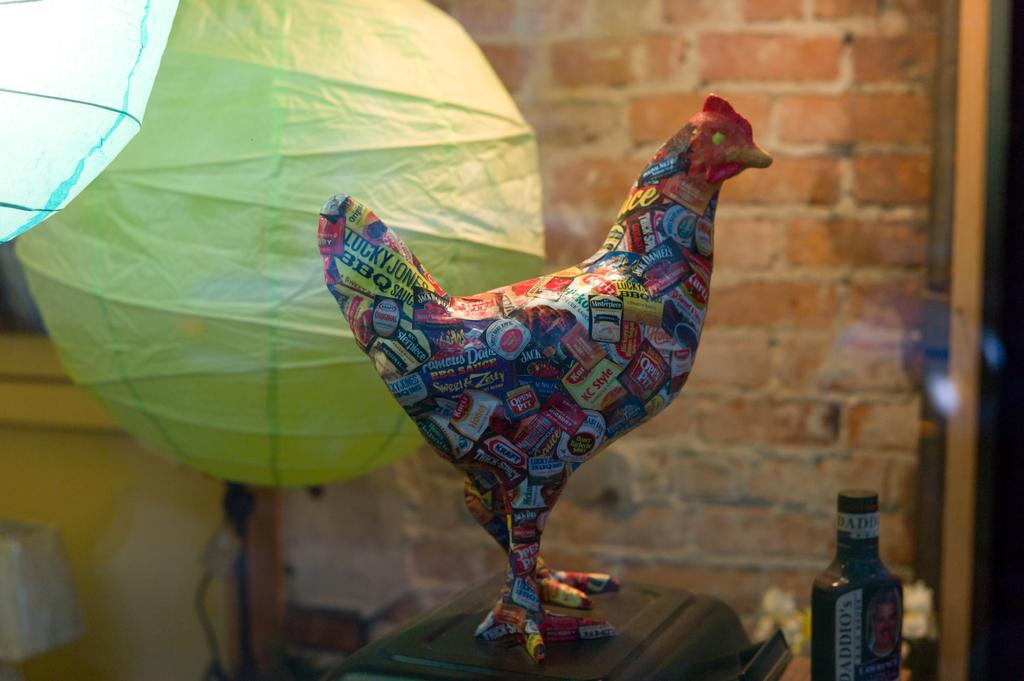What is the main subject of the image? There is a hen made up of paper in the image. What is located at the bottom of the image? There is a box at the bottom of the image. What can be seen in the background of the image? There is a wall made up of bricks in the background of the image. What is present to the left of the image? There are paper balloons to the left of the image. How many pizzas are being served on the chairs in the image? There are no chairs or pizzas present in the image. What is the color of the moon in the image? There is no moon present in the image. 